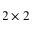Convert formula to latex. <formula><loc_0><loc_0><loc_500><loc_500>2 \times 2</formula> 